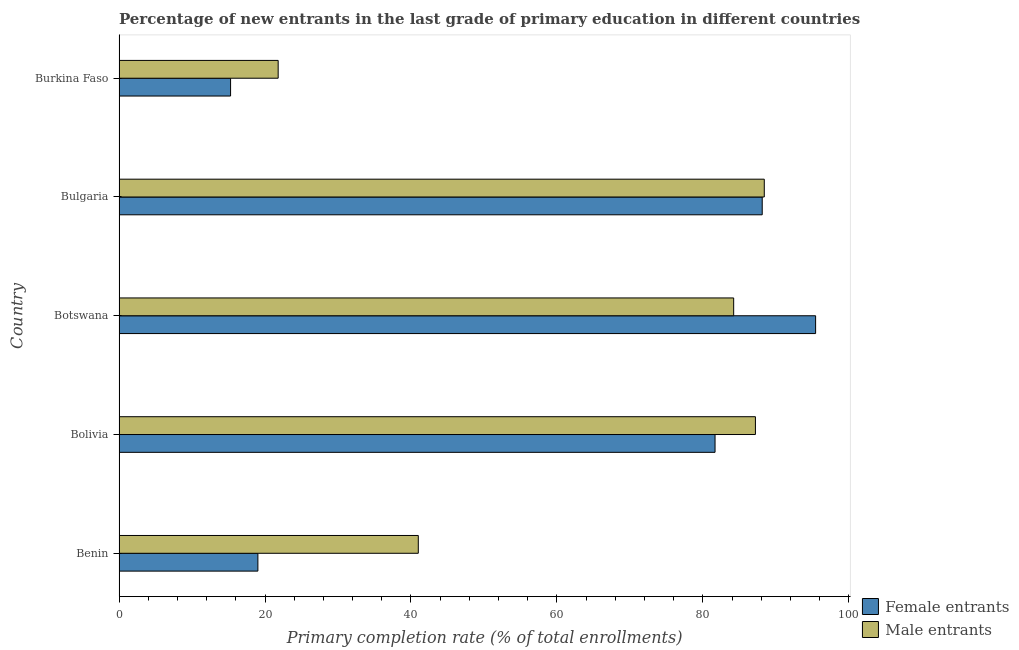How many different coloured bars are there?
Provide a short and direct response. 2. Are the number of bars per tick equal to the number of legend labels?
Make the answer very short. Yes. Are the number of bars on each tick of the Y-axis equal?
Make the answer very short. Yes. How many bars are there on the 4th tick from the bottom?
Offer a terse response. 2. What is the label of the 3rd group of bars from the top?
Give a very brief answer. Botswana. What is the primary completion rate of female entrants in Burkina Faso?
Your answer should be very brief. 15.28. Across all countries, what is the maximum primary completion rate of male entrants?
Offer a very short reply. 88.41. Across all countries, what is the minimum primary completion rate of female entrants?
Offer a very short reply. 15.28. In which country was the primary completion rate of female entrants minimum?
Your answer should be very brief. Burkina Faso. What is the total primary completion rate of female entrants in the graph?
Provide a succinct answer. 299.55. What is the difference between the primary completion rate of female entrants in Benin and that in Bolivia?
Offer a terse response. -62.64. What is the difference between the primary completion rate of female entrants in Botswana and the primary completion rate of male entrants in Bulgaria?
Your response must be concise. 7.03. What is the average primary completion rate of male entrants per country?
Ensure brevity in your answer.  64.53. What is the difference between the primary completion rate of male entrants and primary completion rate of female entrants in Burkina Faso?
Your answer should be very brief. 6.52. In how many countries, is the primary completion rate of male entrants greater than 56 %?
Ensure brevity in your answer.  3. What is the ratio of the primary completion rate of female entrants in Benin to that in Botswana?
Offer a terse response. 0.2. Is the primary completion rate of male entrants in Benin less than that in Bulgaria?
Your answer should be very brief. Yes. Is the difference between the primary completion rate of male entrants in Benin and Burkina Faso greater than the difference between the primary completion rate of female entrants in Benin and Burkina Faso?
Offer a very short reply. Yes. What is the difference between the highest and the second highest primary completion rate of male entrants?
Keep it short and to the point. 1.21. What is the difference between the highest and the lowest primary completion rate of female entrants?
Make the answer very short. 80.16. What does the 1st bar from the top in Burkina Faso represents?
Keep it short and to the point. Male entrants. What does the 1st bar from the bottom in Bolivia represents?
Provide a succinct answer. Female entrants. How many countries are there in the graph?
Your answer should be compact. 5. What is the difference between two consecutive major ticks on the X-axis?
Make the answer very short. 20. Are the values on the major ticks of X-axis written in scientific E-notation?
Provide a short and direct response. No. How many legend labels are there?
Your answer should be very brief. 2. What is the title of the graph?
Make the answer very short. Percentage of new entrants in the last grade of primary education in different countries. Does "Secondary" appear as one of the legend labels in the graph?
Make the answer very short. No. What is the label or title of the X-axis?
Your answer should be compact. Primary completion rate (% of total enrollments). What is the Primary completion rate (% of total enrollments) of Female entrants in Benin?
Your answer should be very brief. 19.02. What is the Primary completion rate (% of total enrollments) of Male entrants in Benin?
Provide a short and direct response. 41. What is the Primary completion rate (% of total enrollments) in Female entrants in Bolivia?
Ensure brevity in your answer.  81.67. What is the Primary completion rate (% of total enrollments) of Male entrants in Bolivia?
Offer a very short reply. 87.2. What is the Primary completion rate (% of total enrollments) of Female entrants in Botswana?
Provide a succinct answer. 95.45. What is the Primary completion rate (% of total enrollments) in Male entrants in Botswana?
Keep it short and to the point. 84.22. What is the Primary completion rate (% of total enrollments) in Female entrants in Bulgaria?
Your answer should be compact. 88.13. What is the Primary completion rate (% of total enrollments) of Male entrants in Bulgaria?
Offer a very short reply. 88.41. What is the Primary completion rate (% of total enrollments) in Female entrants in Burkina Faso?
Provide a short and direct response. 15.28. What is the Primary completion rate (% of total enrollments) of Male entrants in Burkina Faso?
Provide a succinct answer. 21.8. Across all countries, what is the maximum Primary completion rate (% of total enrollments) of Female entrants?
Keep it short and to the point. 95.45. Across all countries, what is the maximum Primary completion rate (% of total enrollments) of Male entrants?
Ensure brevity in your answer.  88.41. Across all countries, what is the minimum Primary completion rate (% of total enrollments) of Female entrants?
Offer a terse response. 15.28. Across all countries, what is the minimum Primary completion rate (% of total enrollments) in Male entrants?
Make the answer very short. 21.8. What is the total Primary completion rate (% of total enrollments) of Female entrants in the graph?
Your answer should be very brief. 299.55. What is the total Primary completion rate (% of total enrollments) of Male entrants in the graph?
Keep it short and to the point. 322.64. What is the difference between the Primary completion rate (% of total enrollments) of Female entrants in Benin and that in Bolivia?
Offer a very short reply. -62.64. What is the difference between the Primary completion rate (% of total enrollments) in Male entrants in Benin and that in Bolivia?
Your response must be concise. -46.2. What is the difference between the Primary completion rate (% of total enrollments) of Female entrants in Benin and that in Botswana?
Your response must be concise. -76.42. What is the difference between the Primary completion rate (% of total enrollments) in Male entrants in Benin and that in Botswana?
Provide a short and direct response. -43.22. What is the difference between the Primary completion rate (% of total enrollments) in Female entrants in Benin and that in Bulgaria?
Your response must be concise. -69.11. What is the difference between the Primary completion rate (% of total enrollments) in Male entrants in Benin and that in Bulgaria?
Keep it short and to the point. -47.41. What is the difference between the Primary completion rate (% of total enrollments) in Female entrants in Benin and that in Burkina Faso?
Keep it short and to the point. 3.74. What is the difference between the Primary completion rate (% of total enrollments) of Male entrants in Benin and that in Burkina Faso?
Give a very brief answer. 19.2. What is the difference between the Primary completion rate (% of total enrollments) in Female entrants in Bolivia and that in Botswana?
Provide a short and direct response. -13.78. What is the difference between the Primary completion rate (% of total enrollments) of Male entrants in Bolivia and that in Botswana?
Offer a terse response. 2.98. What is the difference between the Primary completion rate (% of total enrollments) in Female entrants in Bolivia and that in Bulgaria?
Keep it short and to the point. -6.46. What is the difference between the Primary completion rate (% of total enrollments) in Male entrants in Bolivia and that in Bulgaria?
Your answer should be very brief. -1.21. What is the difference between the Primary completion rate (% of total enrollments) of Female entrants in Bolivia and that in Burkina Faso?
Your answer should be compact. 66.38. What is the difference between the Primary completion rate (% of total enrollments) in Male entrants in Bolivia and that in Burkina Faso?
Give a very brief answer. 65.4. What is the difference between the Primary completion rate (% of total enrollments) in Female entrants in Botswana and that in Bulgaria?
Provide a short and direct response. 7.31. What is the difference between the Primary completion rate (% of total enrollments) of Male entrants in Botswana and that in Bulgaria?
Keep it short and to the point. -4.19. What is the difference between the Primary completion rate (% of total enrollments) of Female entrants in Botswana and that in Burkina Faso?
Provide a succinct answer. 80.16. What is the difference between the Primary completion rate (% of total enrollments) of Male entrants in Botswana and that in Burkina Faso?
Keep it short and to the point. 62.42. What is the difference between the Primary completion rate (% of total enrollments) in Female entrants in Bulgaria and that in Burkina Faso?
Offer a very short reply. 72.85. What is the difference between the Primary completion rate (% of total enrollments) in Male entrants in Bulgaria and that in Burkina Faso?
Your answer should be compact. 66.61. What is the difference between the Primary completion rate (% of total enrollments) in Female entrants in Benin and the Primary completion rate (% of total enrollments) in Male entrants in Bolivia?
Provide a succinct answer. -68.17. What is the difference between the Primary completion rate (% of total enrollments) in Female entrants in Benin and the Primary completion rate (% of total enrollments) in Male entrants in Botswana?
Make the answer very short. -65.19. What is the difference between the Primary completion rate (% of total enrollments) in Female entrants in Benin and the Primary completion rate (% of total enrollments) in Male entrants in Bulgaria?
Offer a very short reply. -69.39. What is the difference between the Primary completion rate (% of total enrollments) of Female entrants in Benin and the Primary completion rate (% of total enrollments) of Male entrants in Burkina Faso?
Offer a very short reply. -2.78. What is the difference between the Primary completion rate (% of total enrollments) of Female entrants in Bolivia and the Primary completion rate (% of total enrollments) of Male entrants in Botswana?
Provide a succinct answer. -2.55. What is the difference between the Primary completion rate (% of total enrollments) in Female entrants in Bolivia and the Primary completion rate (% of total enrollments) in Male entrants in Bulgaria?
Offer a terse response. -6.75. What is the difference between the Primary completion rate (% of total enrollments) in Female entrants in Bolivia and the Primary completion rate (% of total enrollments) in Male entrants in Burkina Faso?
Offer a terse response. 59.86. What is the difference between the Primary completion rate (% of total enrollments) of Female entrants in Botswana and the Primary completion rate (% of total enrollments) of Male entrants in Bulgaria?
Your response must be concise. 7.03. What is the difference between the Primary completion rate (% of total enrollments) of Female entrants in Botswana and the Primary completion rate (% of total enrollments) of Male entrants in Burkina Faso?
Provide a succinct answer. 73.64. What is the difference between the Primary completion rate (% of total enrollments) of Female entrants in Bulgaria and the Primary completion rate (% of total enrollments) of Male entrants in Burkina Faso?
Offer a terse response. 66.33. What is the average Primary completion rate (% of total enrollments) in Female entrants per country?
Your response must be concise. 59.91. What is the average Primary completion rate (% of total enrollments) of Male entrants per country?
Your answer should be very brief. 64.53. What is the difference between the Primary completion rate (% of total enrollments) in Female entrants and Primary completion rate (% of total enrollments) in Male entrants in Benin?
Offer a very short reply. -21.98. What is the difference between the Primary completion rate (% of total enrollments) of Female entrants and Primary completion rate (% of total enrollments) of Male entrants in Bolivia?
Offer a terse response. -5.53. What is the difference between the Primary completion rate (% of total enrollments) in Female entrants and Primary completion rate (% of total enrollments) in Male entrants in Botswana?
Offer a terse response. 11.23. What is the difference between the Primary completion rate (% of total enrollments) of Female entrants and Primary completion rate (% of total enrollments) of Male entrants in Bulgaria?
Ensure brevity in your answer.  -0.28. What is the difference between the Primary completion rate (% of total enrollments) of Female entrants and Primary completion rate (% of total enrollments) of Male entrants in Burkina Faso?
Your response must be concise. -6.52. What is the ratio of the Primary completion rate (% of total enrollments) in Female entrants in Benin to that in Bolivia?
Offer a very short reply. 0.23. What is the ratio of the Primary completion rate (% of total enrollments) in Male entrants in Benin to that in Bolivia?
Provide a short and direct response. 0.47. What is the ratio of the Primary completion rate (% of total enrollments) of Female entrants in Benin to that in Botswana?
Make the answer very short. 0.2. What is the ratio of the Primary completion rate (% of total enrollments) in Male entrants in Benin to that in Botswana?
Provide a short and direct response. 0.49. What is the ratio of the Primary completion rate (% of total enrollments) in Female entrants in Benin to that in Bulgaria?
Give a very brief answer. 0.22. What is the ratio of the Primary completion rate (% of total enrollments) in Male entrants in Benin to that in Bulgaria?
Give a very brief answer. 0.46. What is the ratio of the Primary completion rate (% of total enrollments) in Female entrants in Benin to that in Burkina Faso?
Provide a succinct answer. 1.24. What is the ratio of the Primary completion rate (% of total enrollments) in Male entrants in Benin to that in Burkina Faso?
Give a very brief answer. 1.88. What is the ratio of the Primary completion rate (% of total enrollments) in Female entrants in Bolivia to that in Botswana?
Offer a terse response. 0.86. What is the ratio of the Primary completion rate (% of total enrollments) of Male entrants in Bolivia to that in Botswana?
Keep it short and to the point. 1.04. What is the ratio of the Primary completion rate (% of total enrollments) in Female entrants in Bolivia to that in Bulgaria?
Offer a terse response. 0.93. What is the ratio of the Primary completion rate (% of total enrollments) in Male entrants in Bolivia to that in Bulgaria?
Your answer should be compact. 0.99. What is the ratio of the Primary completion rate (% of total enrollments) in Female entrants in Bolivia to that in Burkina Faso?
Give a very brief answer. 5.34. What is the ratio of the Primary completion rate (% of total enrollments) of Male entrants in Bolivia to that in Burkina Faso?
Make the answer very short. 4. What is the ratio of the Primary completion rate (% of total enrollments) of Female entrants in Botswana to that in Bulgaria?
Provide a succinct answer. 1.08. What is the ratio of the Primary completion rate (% of total enrollments) in Male entrants in Botswana to that in Bulgaria?
Make the answer very short. 0.95. What is the ratio of the Primary completion rate (% of total enrollments) of Female entrants in Botswana to that in Burkina Faso?
Your response must be concise. 6.25. What is the ratio of the Primary completion rate (% of total enrollments) in Male entrants in Botswana to that in Burkina Faso?
Your response must be concise. 3.86. What is the ratio of the Primary completion rate (% of total enrollments) of Female entrants in Bulgaria to that in Burkina Faso?
Provide a succinct answer. 5.77. What is the ratio of the Primary completion rate (% of total enrollments) in Male entrants in Bulgaria to that in Burkina Faso?
Your answer should be compact. 4.05. What is the difference between the highest and the second highest Primary completion rate (% of total enrollments) in Female entrants?
Your answer should be compact. 7.31. What is the difference between the highest and the second highest Primary completion rate (% of total enrollments) of Male entrants?
Provide a succinct answer. 1.21. What is the difference between the highest and the lowest Primary completion rate (% of total enrollments) of Female entrants?
Provide a short and direct response. 80.16. What is the difference between the highest and the lowest Primary completion rate (% of total enrollments) in Male entrants?
Provide a succinct answer. 66.61. 